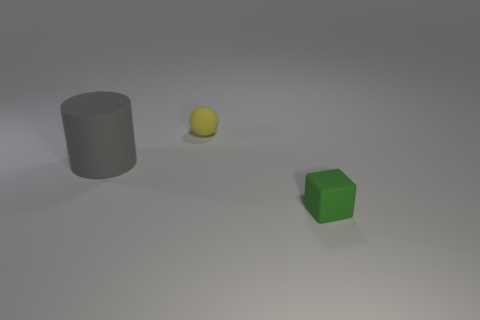Is there anything else that is the same size as the cylinder?
Keep it short and to the point. No. Are any large green things visible?
Your response must be concise. No. What number of small objects are either matte objects or green rubber blocks?
Your answer should be very brief. 2. Are there more rubber things behind the green object than cylinders that are left of the big cylinder?
Give a very brief answer. Yes. Does the large cylinder have the same material as the small thing to the left of the tiny rubber cube?
Your response must be concise. Yes. What is the color of the tiny matte block?
Offer a terse response. Green. What shape is the matte thing in front of the big gray cylinder?
Your answer should be very brief. Cube. What number of gray things are either big cylinders or spheres?
Your answer should be very brief. 1. There is a small thing that is made of the same material as the block; what color is it?
Offer a terse response. Yellow. There is a tiny rubber cube; is it the same color as the tiny thing behind the gray rubber thing?
Your answer should be compact. No. 